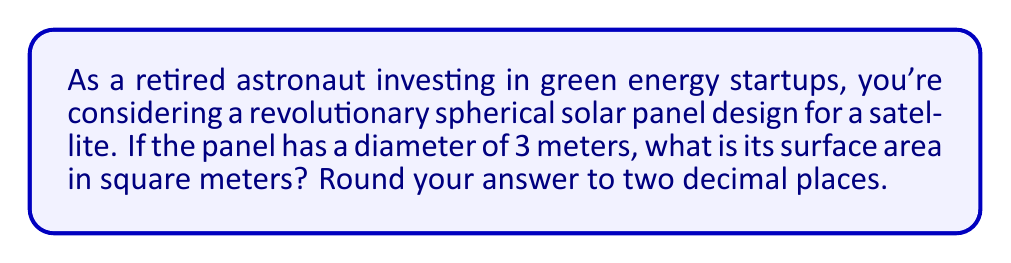Could you help me with this problem? Let's approach this step-by-step:

1) The formula for the surface area of a sphere is:

   $$A = 4\pi r^2$$

   where $A$ is the surface area and $r$ is the radius.

2) We're given the diameter, which is 3 meters. The radius is half of the diameter:

   $$r = \frac{3}{2} = 1.5 \text{ meters}$$

3) Now, let's substitute this into our formula:

   $$A = 4\pi (1.5)^2$$

4) Let's calculate:

   $$A = 4\pi (2.25)$$
   $$A = 9\pi$$

5) Using 3.14159 as an approximation for $\pi$:

   $$A \approx 9 * 3.14159 = 28.27431 \text{ square meters}$$

6) Rounding to two decimal places:

   $$A \approx 28.27 \text{ square meters}$$
Answer: 28.27 m² 